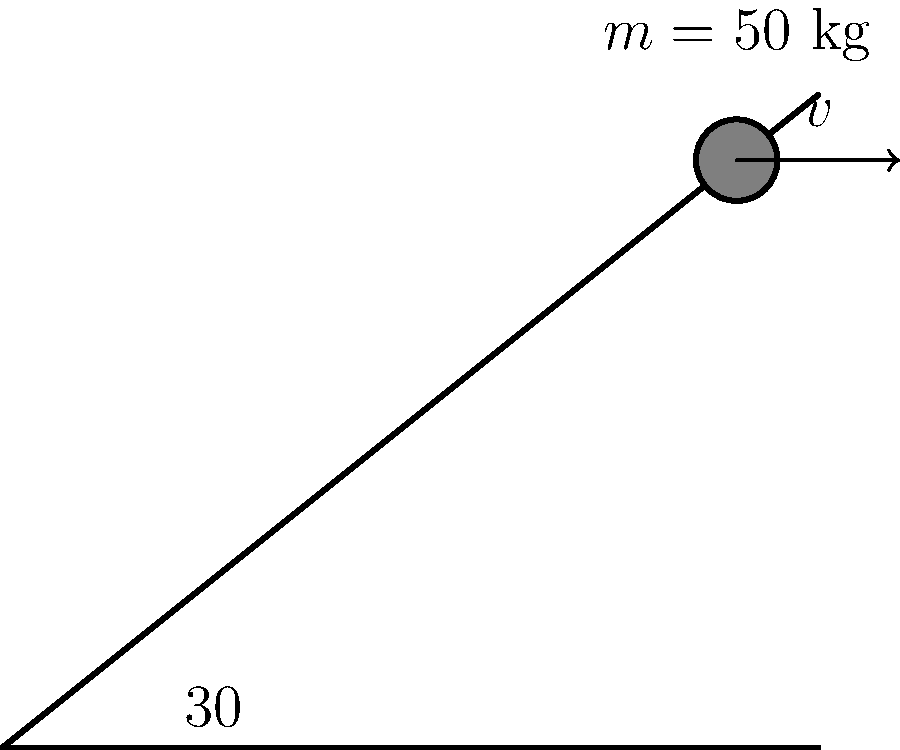As a music teacher, you've noticed your child's interest in skateboarding and want to understand the physics behind it. A skateboarder with a mass of 50 kg is riding up a ramp at a velocity of 5 m/s. Calculate the skateboarder's momentum at this instant. To solve this problem, we'll follow these steps:

1. Recall the formula for momentum:
   
   Momentum ($p$) = mass ($m$) × velocity ($v$)

2. We're given:
   - Mass ($m$) = 50 kg
   - Velocity ($v$) = 5 m/s

3. Let's substitute these values into the formula:

   $p = m \times v$
   $p = 50 \text{ kg} \times 5 \text{ m/s}$

4. Perform the multiplication:

   $p = 250 \text{ kg} \cdot \text{m/s}$

5. The units for momentum are kg⋅m/s, which is correct.

Therefore, the skateboarder's momentum is 250 kg⋅m/s.
Answer: 250 kg⋅m/s 